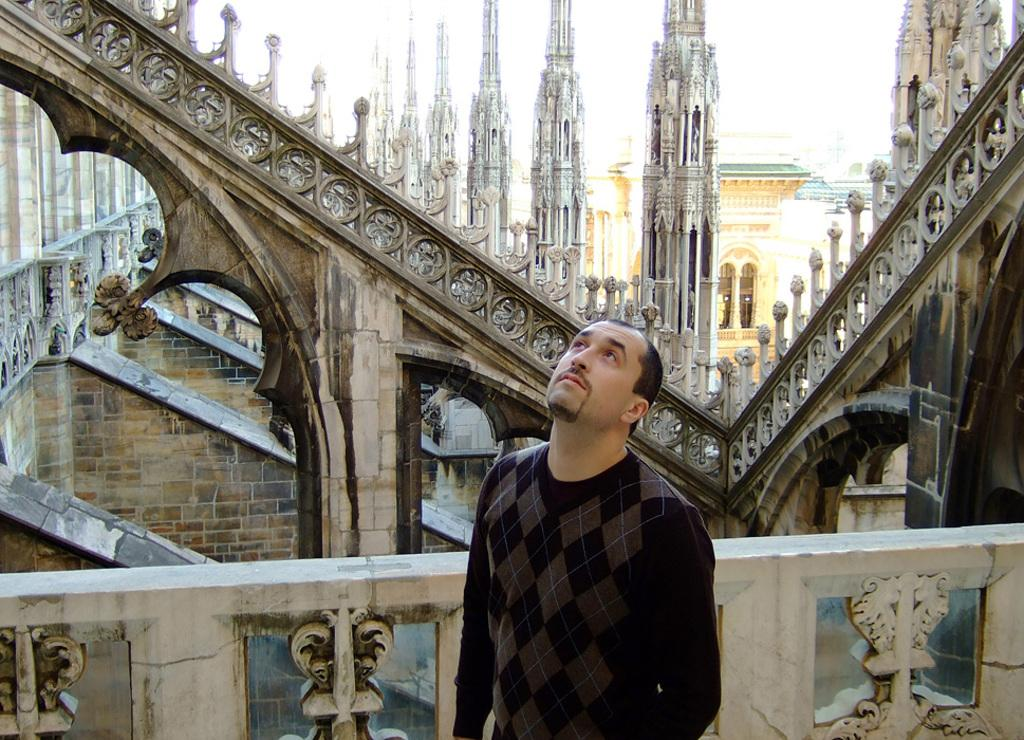What is the main subject of the image? There is a person standing in the center of the image. What can be seen in the distance behind the person? There are buildings in the background of the image. What object is present near the person? There is a railing visible in the image. How many rings are visible on the person's fingers in the image? There is no information about rings or the person's fingers in the provided facts, so we cannot determine the number of rings visible. 